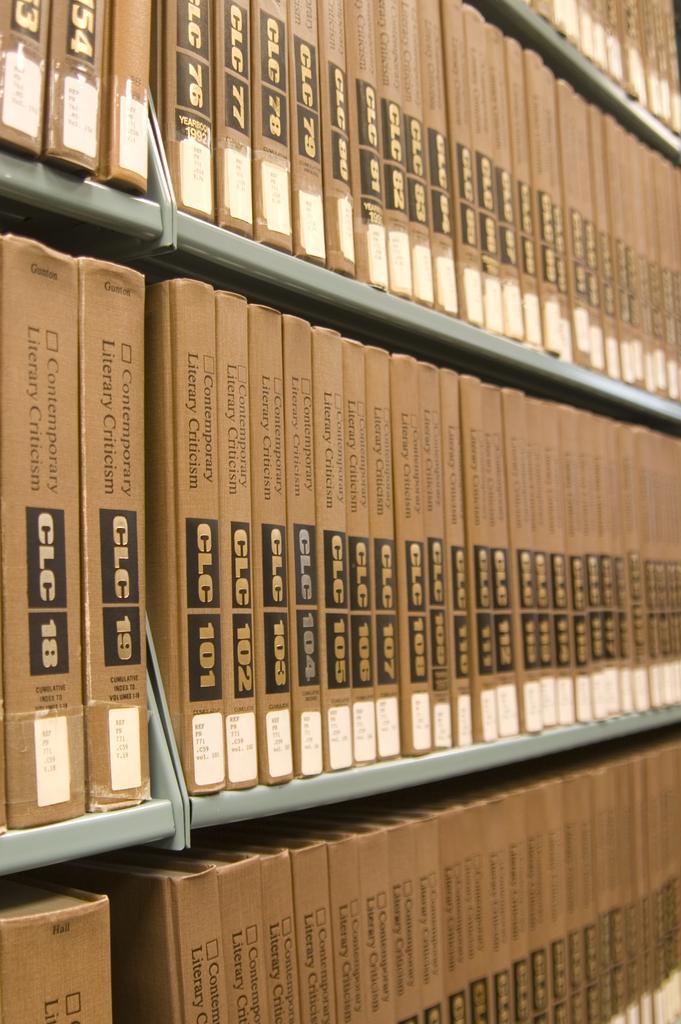Could you give a brief overview of what you see in this image? There are books arranged on the gray color shelves. On the boxes, there are texts and stickers. 